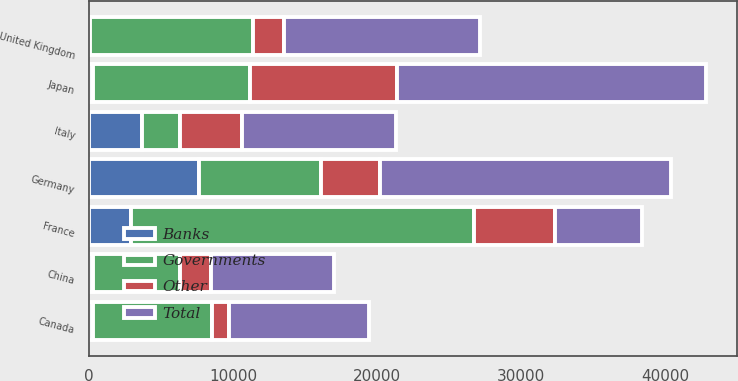Convert chart to OTSL. <chart><loc_0><loc_0><loc_500><loc_500><stacked_bar_chart><ecel><fcel>France<fcel>Japan<fcel>Germany<fcel>United Kingdom<fcel>Italy<fcel>Canada<fcel>China<nl><fcel>Other<fcel>5596<fcel>10254<fcel>4072<fcel>2170<fcel>4326<fcel>1173<fcel>2189<nl><fcel>Banks<fcel>2904<fcel>297<fcel>7652<fcel>42<fcel>3691<fcel>253<fcel>254<nl><fcel>Governments<fcel>23854<fcel>10882<fcel>8481<fcel>11361<fcel>2647<fcel>8290<fcel>6069<nl><fcel>Total<fcel>6069<fcel>21433<fcel>20205<fcel>13573<fcel>10664<fcel>9716<fcel>8512<nl></chart> 